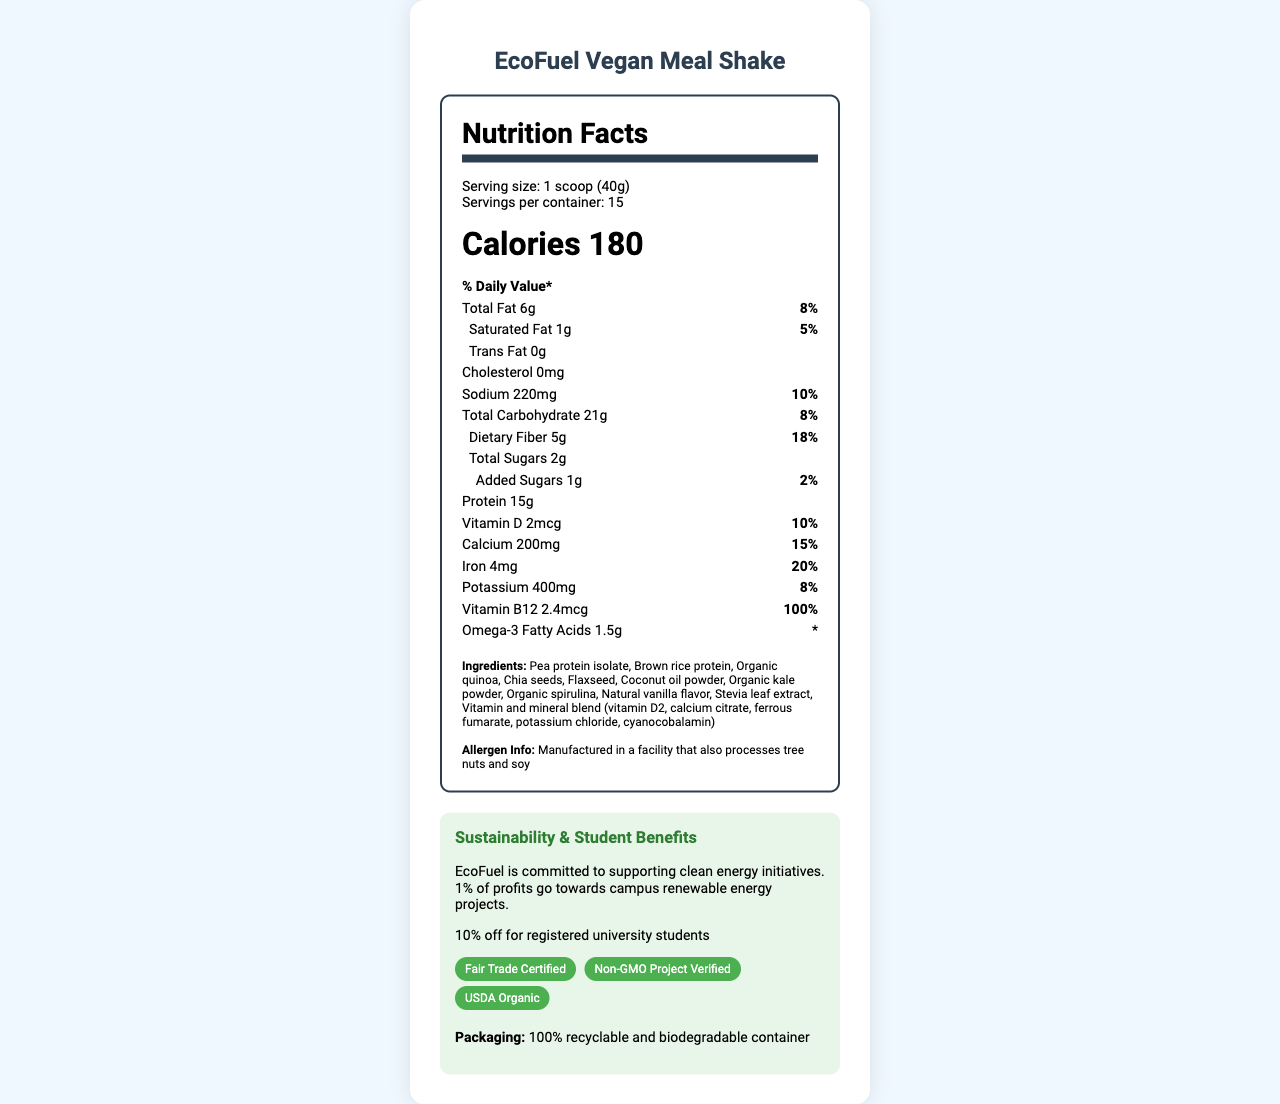what is the serving size? The serving size is explicitly mentioned at the beginning of the nutritional information as "1 scoop (40g)".
Answer: 1 scoop (40g) how many servings are there per container? The number of servings per container is listed right below the serving size information as "Servings per container: 15".
Answer: 15 how many calories are in one serving? The calorie count is prominently displayed as "Calories 180".
Answer: 180 what is the percentage of daily value for total fat in one serving? The daily value percentage for total fat is shown in the nutrient breakdown as "Total Fat 6g 8%".
Answer: 8% which ingredient contributes to both protein and omega-3 fatty acids? Pea protein isolate contributes to protein content, but flaxseed and chia seeds which are also listed among the ingredients, are known to contribute omega-3 fatty acids.
Answer: Pea protein isolate which nutrient has the highest daily value percentage? A. Vitamin D B. Iron C. Vitamin B12 D. Calcium The daily value percentages are shown for each vitamin and mineral; Vitamin B12 has the highest value at 100%.
Answer: C how much sodium is there per serving? A. 100mg B. 220mg C. 350mg The sodium content per serving is listed as "Sodium 220mg" in the nutrient breakdown.
Answer: B is the product non-GMO and organic? The document includes badges that state "Non-GMO Project Verified" and "USDA Organic", confirming both claims.
Answer: Yes does the EcoFuel Vegan Meal Shake support any initiatives? The document notes that "EcoFuel is committed to supporting clean energy initiatives. 1% of profits go towards campus renewable energy projects."
Answer: Yes summarize the main idea of the document The document offers a comprehensive overview of the meal shake's nutritional value, ingredients, eco-friendly packaging, and discounts for students, emphasizing its sustainability efforts and clean energy support.
Answer: The document provides detailed nutritional information for the EcoFuel Vegan Meal Shake, highlighting its vegan ingredients, nutritional content, such as calories, fats, carbohydrates, and various vitamins and minerals. It includes badges that confirm the product's non-GMO and organic certifications, as well as a commitment to sustainability initiatives. Additionally, it encourages student support by offering a discount to registered university students. how many grams of protein does one serving contain? The protein content is displayed prominently in the nutrient section as "Protein 15g".
Answer: 15g what is the primary allergen information provided? The document states this information clearly in the ingredients section under "Allergen Info".
Answer: Manufactured in a facility that also processes tree nuts and soy can the product's iron content meet 50% of the daily value? The iron content per serving meets 20% of the daily value, as mentioned in the document.
Answer: No determine the amount of total sugars per serving? The total sugars per serving are listed explicitly as "Total Sugars 2g".
Answer: 2g what is the preparation instruction? The preparation instructions are provided at the end of the document in a clear, easy-to-read manner.
Answer: Mix 1 scoop with 12 oz of cold water or plant-based milk. Shake well and enjoy! what is the cost of the product? The document does not provide any pricing information for the EcoFuel Vegan Meal Shake.
Answer: Cannot be determined 